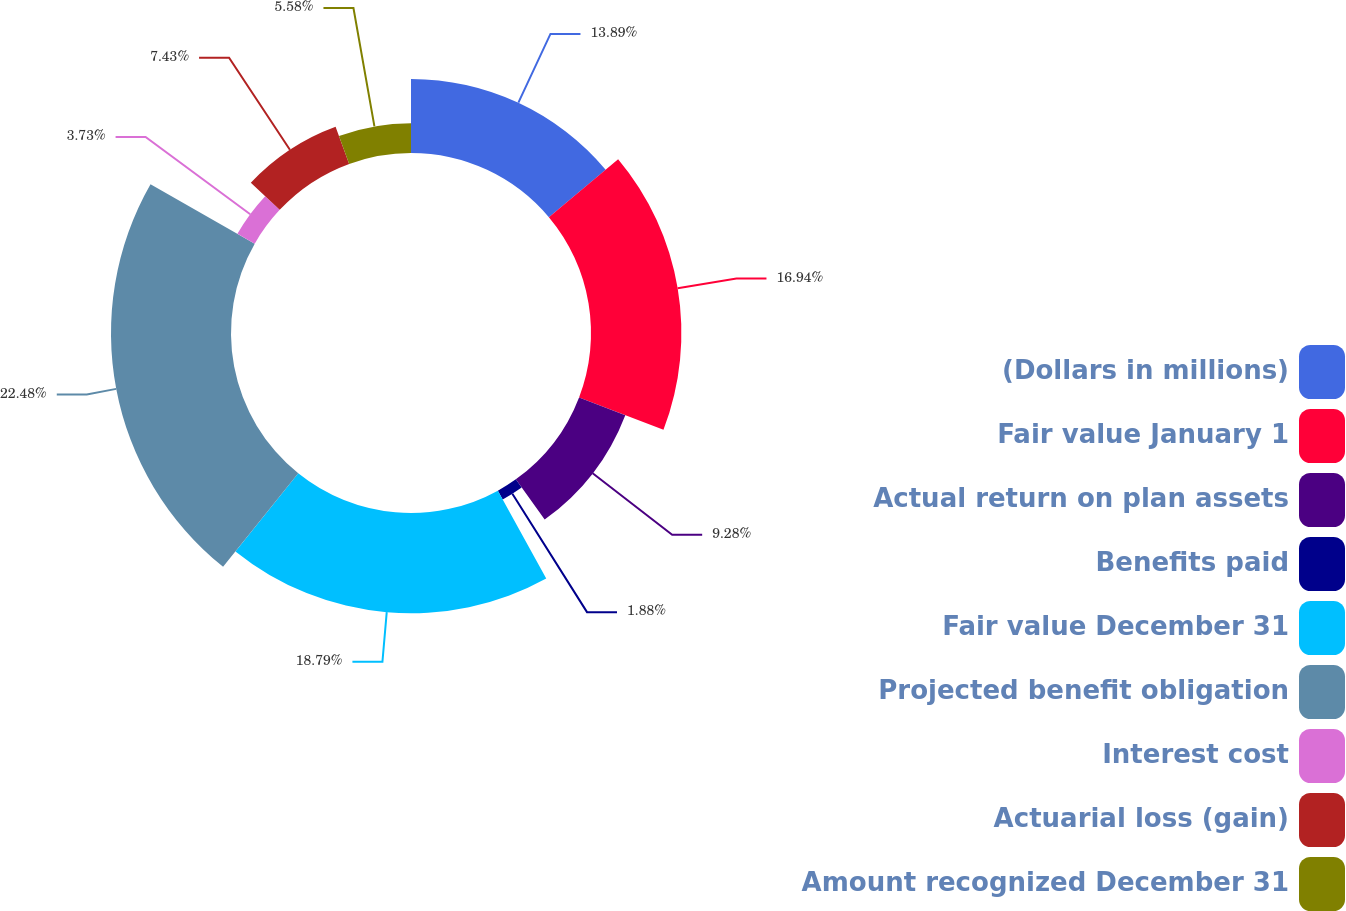Convert chart. <chart><loc_0><loc_0><loc_500><loc_500><pie_chart><fcel>(Dollars in millions)<fcel>Fair value January 1<fcel>Actual return on plan assets<fcel>Benefits paid<fcel>Fair value December 31<fcel>Projected benefit obligation<fcel>Interest cost<fcel>Actuarial loss (gain)<fcel>Amount recognized December 31<nl><fcel>13.89%<fcel>16.94%<fcel>9.28%<fcel>1.88%<fcel>18.79%<fcel>22.49%<fcel>3.73%<fcel>7.43%<fcel>5.58%<nl></chart> 